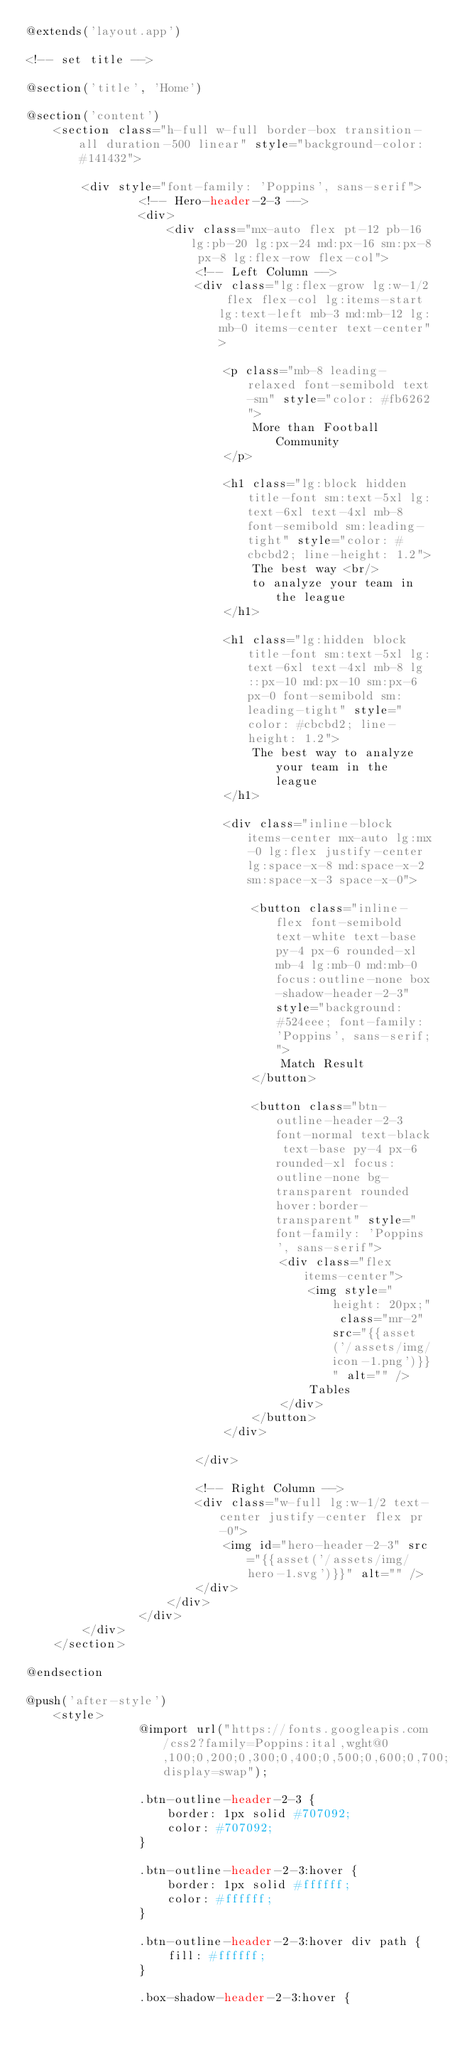Convert code to text. <code><loc_0><loc_0><loc_500><loc_500><_PHP_>@extends('layout.app')

<!-- set title -->

@section('title', 'Home')

@section('content')
    <section class="h-full w-full border-box transition-all duration-500 linear" style="background-color: #141432">
            
        <div style="font-family: 'Poppins', sans-serif">
                <!-- Hero-header-2-3 -->
                <div>
                    <div class="mx-auto flex pt-12 pb-16 lg:pb-20 lg:px-24 md:px-16 sm:px-8 px-8 lg:flex-row flex-col">
                        <!-- Left Column -->
                        <div class="lg:flex-grow lg:w-1/2 flex flex-col lg:items-start lg:text-left mb-3 md:mb-12 lg:mb-0 items-center text-center">

                            <p class="mb-8 leading-relaxed font-semibold text-sm" style="color: #fb6262">
                                More than Football Community
                            </p>

                            <h1 class="lg:block hidden title-font sm:text-5xl lg:text-6xl text-4xl mb-8 font-semibold sm:leading-tight" style="color: #cbcbd2; line-height: 1.2">
                                The best way <br/>
                                to analyze your team in the league
                            </h1>

                            <h1 class="lg:hidden block title-font sm:text-5xl lg:text-6xl text-4xl mb-8 lg::px-10 md:px-10 sm:px-6 px-0 font-semibold sm:leading-tight" style="color: #cbcbd2; line-height: 1.2">
                                The best way to analyze your team in the league
                            </h1>

                            <div class="inline-block items-center mx-auto lg:mx-0 lg:flex justify-center lg:space-x-8 md:space-x-2 sm:space-x-3 space-x-0">

                                <button class="inline-flex font-semibold text-white text-base py-4 px-6 rounded-xl mb-4 lg:mb-0 md:mb-0 focus:outline-none box-shadow-header-2-3" style="background: #524eee; font-family: 'Poppins', sans-serif;">
                                    Match Result
                                </button>

                                <button class="btn-outline-header-2-3 font-normal text-black text-base py-4 px-6 rounded-xl focus:outline-none bg-transparent rounded hover:border-transparent" style="font-family: 'Poppins', sans-serif">
                                    <div class="flex items-center">
                                        <img style="height: 20px;" class="mr-2" src="{{asset('/assets/img/icon-1.png')}}" alt="" />
                                        Tables
                                    </div>
                                </button>
                            </div>

                        </div>

                        <!-- Right Column -->
                        <div class="w-full lg:w-1/2 text-center justify-center flex pr-0">
                            <img id="hero-header-2-3" src="{{asset('/assets/img/hero-1.svg')}}" alt="" />
                        </div>
                    </div>
                </div>
        </div>
    </section>

@endsection

@push('after-style')
    <style>
                @import url("https://fonts.googleapis.com/css2?family=Poppins:ital,wght@0,100;0,200;0,300;0,400;0,500;0,600;0,700;0,800;0,900;1,100;1,200;1,300;1,400;1,500;1,600;1,700;1,800;1,900&display=swap");
                
                .btn-outline-header-2-3 {
                    border: 1px solid #707092;
                    color: #707092;
                }
                
                .btn-outline-header-2-3:hover {
                    border: 1px solid #ffffff;
                    color: #ffffff;
                }
                
                .btn-outline-header-2-3:hover div path {
                    fill: #ffffff;
                }
                
                .box-shadow-header-2-3:hover {</code> 